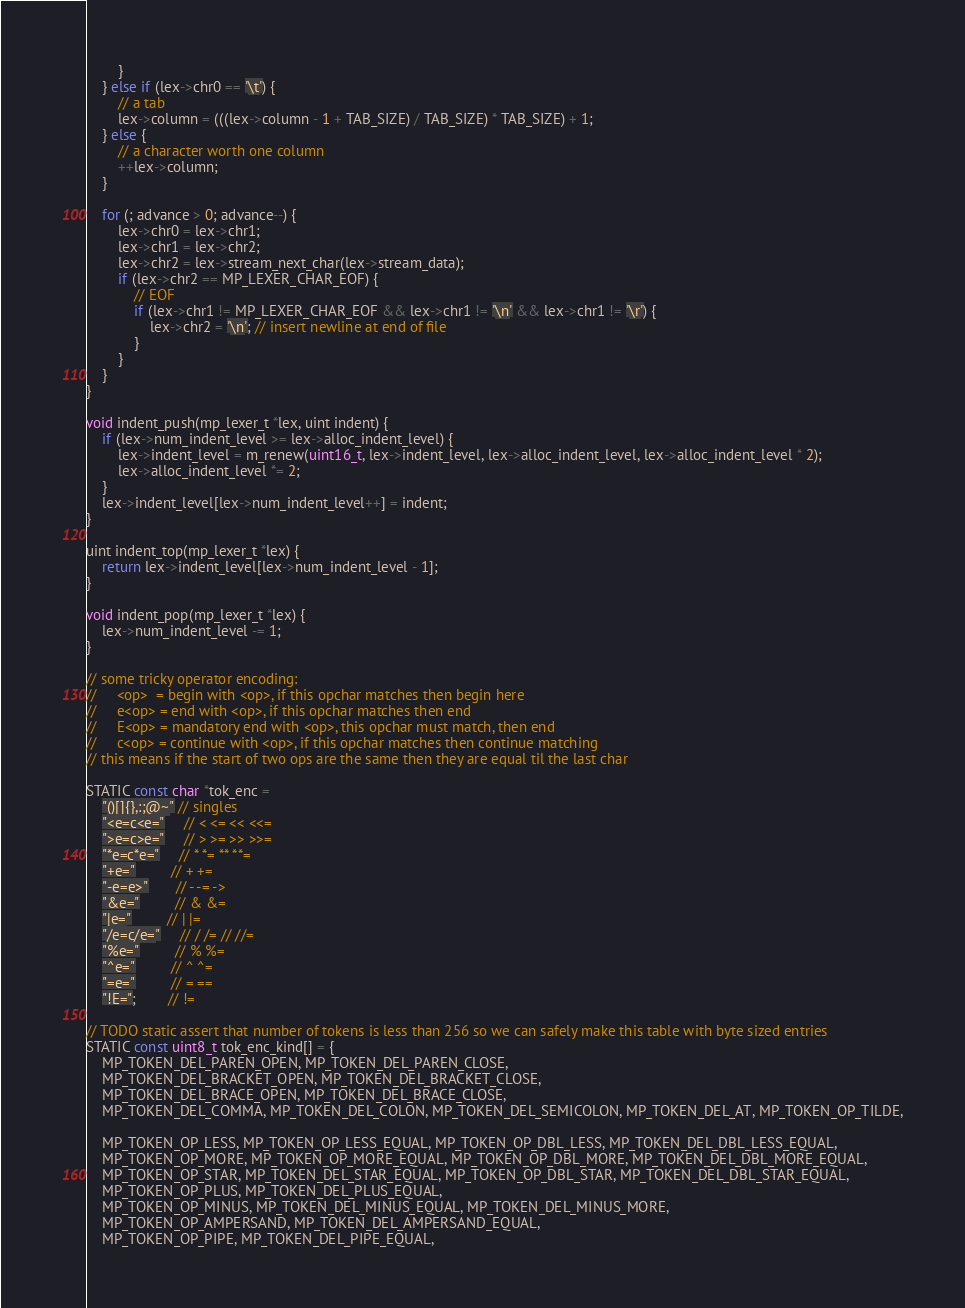Convert code to text. <code><loc_0><loc_0><loc_500><loc_500><_C_>        }
    } else if (lex->chr0 == '\t') {
        // a tab
        lex->column = (((lex->column - 1 + TAB_SIZE) / TAB_SIZE) * TAB_SIZE) + 1;
    } else {
        // a character worth one column
        ++lex->column;
    }

    for (; advance > 0; advance--) {
        lex->chr0 = lex->chr1;
        lex->chr1 = lex->chr2;
        lex->chr2 = lex->stream_next_char(lex->stream_data);
        if (lex->chr2 == MP_LEXER_CHAR_EOF) {
            // EOF
            if (lex->chr1 != MP_LEXER_CHAR_EOF && lex->chr1 != '\n' && lex->chr1 != '\r') {
                lex->chr2 = '\n'; // insert newline at end of file
            }
        }
    }
}

void indent_push(mp_lexer_t *lex, uint indent) {
    if (lex->num_indent_level >= lex->alloc_indent_level) {
        lex->indent_level = m_renew(uint16_t, lex->indent_level, lex->alloc_indent_level, lex->alloc_indent_level * 2);
        lex->alloc_indent_level *= 2;
    }
    lex->indent_level[lex->num_indent_level++] = indent;
}

uint indent_top(mp_lexer_t *lex) {
    return lex->indent_level[lex->num_indent_level - 1];
}

void indent_pop(mp_lexer_t *lex) {
    lex->num_indent_level -= 1;
}

// some tricky operator encoding:
//     <op>  = begin with <op>, if this opchar matches then begin here
//     e<op> = end with <op>, if this opchar matches then end
//     E<op> = mandatory end with <op>, this opchar must match, then end
//     c<op> = continue with <op>, if this opchar matches then continue matching
// this means if the start of two ops are the same then they are equal til the last char

STATIC const char *tok_enc =
    "()[]{},:;@~" // singles
    "<e=c<e="     // < <= << <<=
    ">e=c>e="     // > >= >> >>=
    "*e=c*e="     // * *= ** **=
    "+e="         // + +=
    "-e=e>"       // - -= ->
    "&e="         // & &=
    "|e="         // | |=
    "/e=c/e="     // / /= // //=
    "%e="         // % %=
    "^e="         // ^ ^=
    "=e="         // = ==
    "!E=";        // !=

// TODO static assert that number of tokens is less than 256 so we can safely make this table with byte sized entries
STATIC const uint8_t tok_enc_kind[] = {
    MP_TOKEN_DEL_PAREN_OPEN, MP_TOKEN_DEL_PAREN_CLOSE,
    MP_TOKEN_DEL_BRACKET_OPEN, MP_TOKEN_DEL_BRACKET_CLOSE,
    MP_TOKEN_DEL_BRACE_OPEN, MP_TOKEN_DEL_BRACE_CLOSE,
    MP_TOKEN_DEL_COMMA, MP_TOKEN_DEL_COLON, MP_TOKEN_DEL_SEMICOLON, MP_TOKEN_DEL_AT, MP_TOKEN_OP_TILDE,

    MP_TOKEN_OP_LESS, MP_TOKEN_OP_LESS_EQUAL, MP_TOKEN_OP_DBL_LESS, MP_TOKEN_DEL_DBL_LESS_EQUAL,
    MP_TOKEN_OP_MORE, MP_TOKEN_OP_MORE_EQUAL, MP_TOKEN_OP_DBL_MORE, MP_TOKEN_DEL_DBL_MORE_EQUAL,
    MP_TOKEN_OP_STAR, MP_TOKEN_DEL_STAR_EQUAL, MP_TOKEN_OP_DBL_STAR, MP_TOKEN_DEL_DBL_STAR_EQUAL,
    MP_TOKEN_OP_PLUS, MP_TOKEN_DEL_PLUS_EQUAL,
    MP_TOKEN_OP_MINUS, MP_TOKEN_DEL_MINUS_EQUAL, MP_TOKEN_DEL_MINUS_MORE,
    MP_TOKEN_OP_AMPERSAND, MP_TOKEN_DEL_AMPERSAND_EQUAL,
    MP_TOKEN_OP_PIPE, MP_TOKEN_DEL_PIPE_EQUAL,</code> 